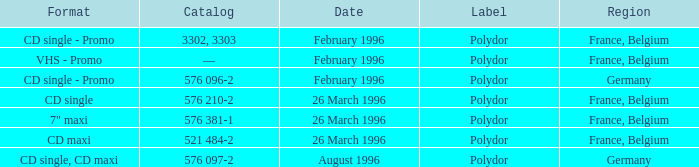Name the catalog for 26 march 1996 576 210-2, 576 381-1, 521 484-2. 